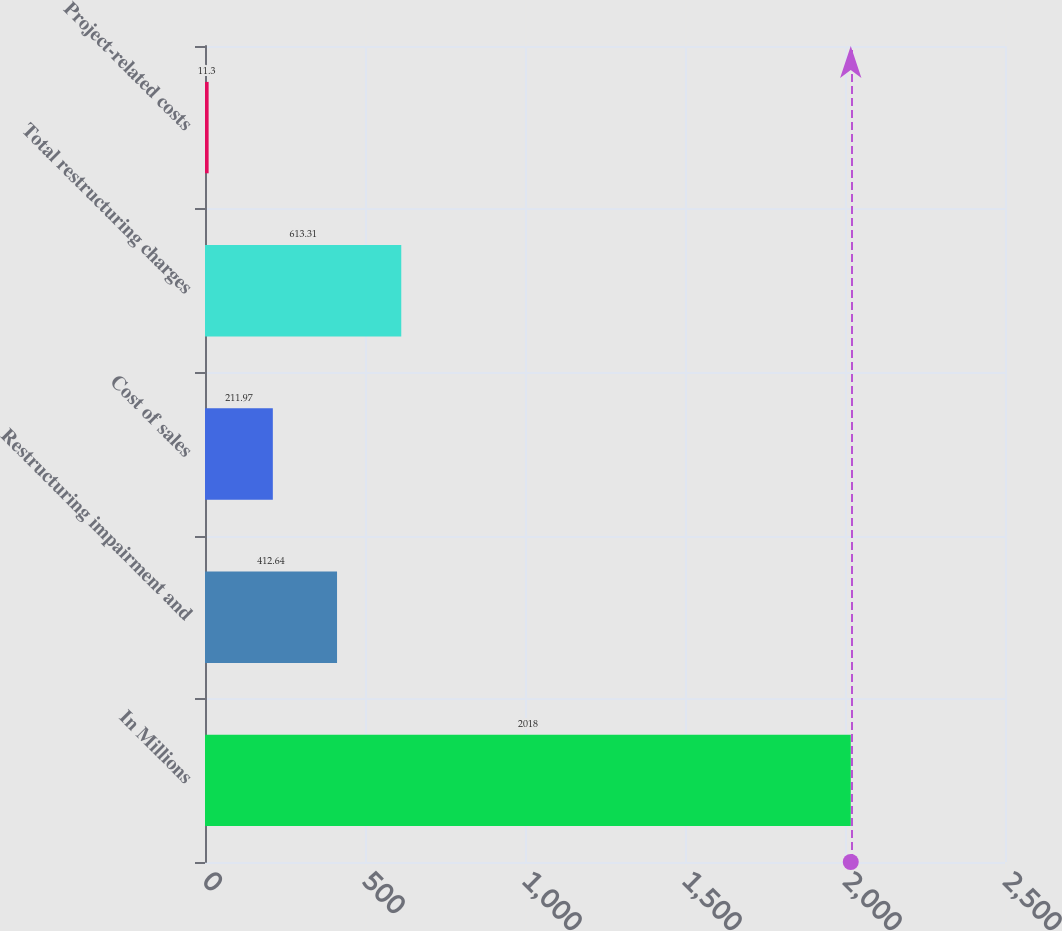<chart> <loc_0><loc_0><loc_500><loc_500><bar_chart><fcel>In Millions<fcel>Restructuring impairment and<fcel>Cost of sales<fcel>Total restructuring charges<fcel>Project-related costs<nl><fcel>2018<fcel>412.64<fcel>211.97<fcel>613.31<fcel>11.3<nl></chart> 